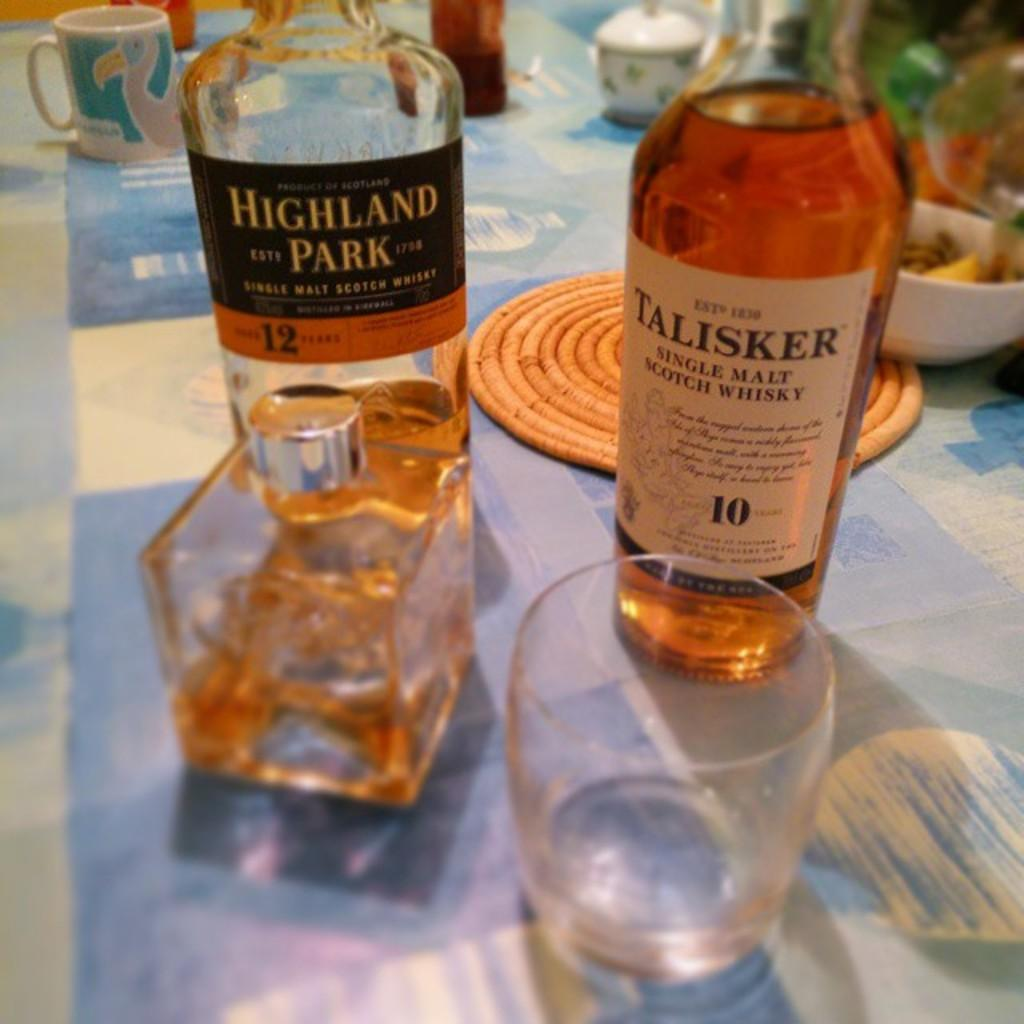<image>
Create a compact narrative representing the image presented. A bottle of Talisker single malt whisky sits next to a different whisky bottle. 